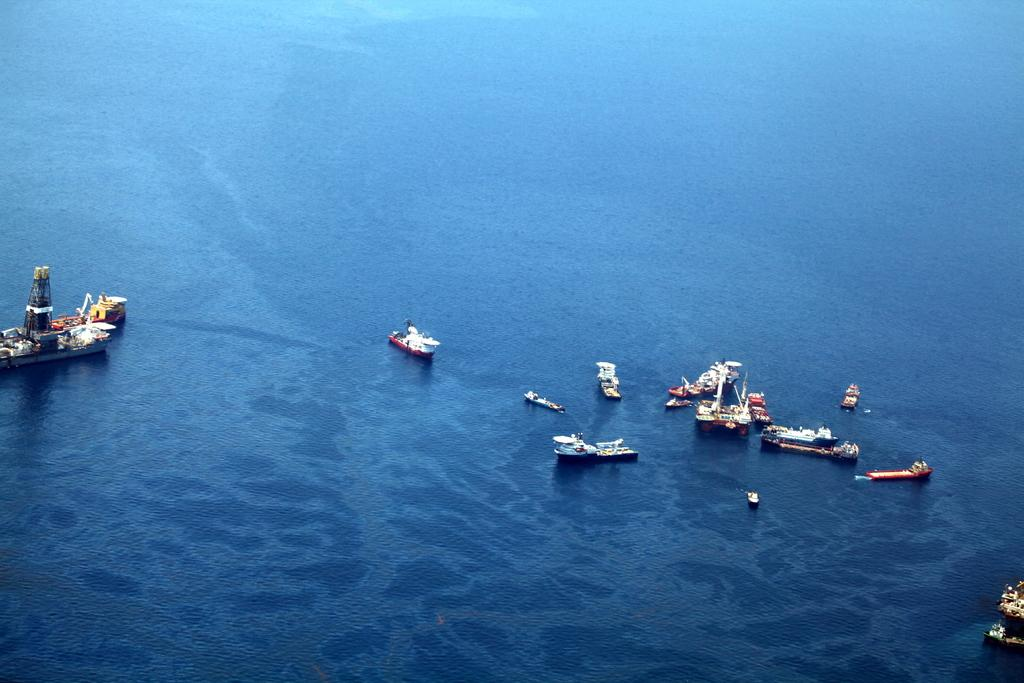What type of vehicles are in the image? There are ships in the image. Where are the ships located? The ships are on the water. Can you see a rabbit hopping on the ships in the image? There is no rabbit present in the image, and the ships are on the water, not on land where a rabbit might hop. 